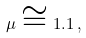<formula> <loc_0><loc_0><loc_500><loc_500>\mu \cong 1 . 1 \, ,</formula> 